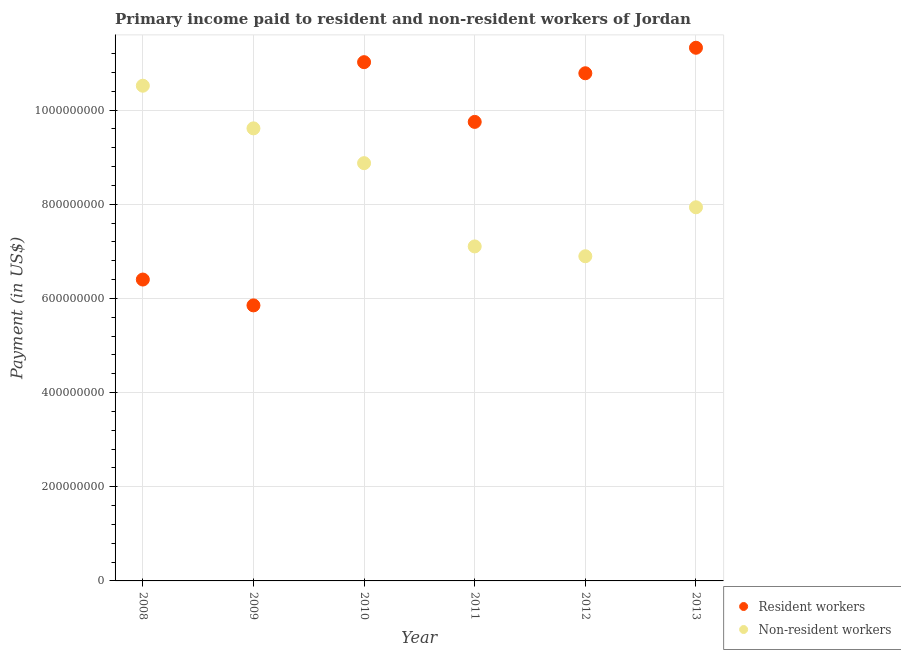What is the payment made to non-resident workers in 2012?
Offer a terse response. 6.90e+08. Across all years, what is the maximum payment made to non-resident workers?
Provide a succinct answer. 1.05e+09. Across all years, what is the minimum payment made to resident workers?
Offer a terse response. 5.85e+08. In which year was the payment made to resident workers maximum?
Provide a succinct answer. 2013. In which year was the payment made to resident workers minimum?
Ensure brevity in your answer.  2009. What is the total payment made to resident workers in the graph?
Keep it short and to the point. 5.51e+09. What is the difference between the payment made to resident workers in 2008 and that in 2012?
Make the answer very short. -4.38e+08. What is the difference between the payment made to resident workers in 2013 and the payment made to non-resident workers in 2008?
Provide a short and direct response. 8.06e+07. What is the average payment made to non-resident workers per year?
Keep it short and to the point. 8.49e+08. In the year 2011, what is the difference between the payment made to non-resident workers and payment made to resident workers?
Offer a very short reply. -2.64e+08. What is the ratio of the payment made to resident workers in 2009 to that in 2011?
Provide a short and direct response. 0.6. Is the payment made to non-resident workers in 2008 less than that in 2013?
Your answer should be compact. No. What is the difference between the highest and the second highest payment made to resident workers?
Give a very brief answer. 3.06e+07. What is the difference between the highest and the lowest payment made to resident workers?
Offer a very short reply. 5.47e+08. In how many years, is the payment made to resident workers greater than the average payment made to resident workers taken over all years?
Offer a terse response. 4. Is the sum of the payment made to resident workers in 2008 and 2010 greater than the maximum payment made to non-resident workers across all years?
Offer a terse response. Yes. Is the payment made to non-resident workers strictly less than the payment made to resident workers over the years?
Keep it short and to the point. No. Does the graph contain any zero values?
Ensure brevity in your answer.  No. Does the graph contain grids?
Keep it short and to the point. Yes. What is the title of the graph?
Provide a succinct answer. Primary income paid to resident and non-resident workers of Jordan. What is the label or title of the X-axis?
Your answer should be compact. Year. What is the label or title of the Y-axis?
Offer a terse response. Payment (in US$). What is the Payment (in US$) of Resident workers in 2008?
Your response must be concise. 6.40e+08. What is the Payment (in US$) of Non-resident workers in 2008?
Offer a very short reply. 1.05e+09. What is the Payment (in US$) of Resident workers in 2009?
Your answer should be very brief. 5.85e+08. What is the Payment (in US$) in Non-resident workers in 2009?
Provide a succinct answer. 9.61e+08. What is the Payment (in US$) in Resident workers in 2010?
Give a very brief answer. 1.10e+09. What is the Payment (in US$) of Non-resident workers in 2010?
Keep it short and to the point. 8.87e+08. What is the Payment (in US$) in Resident workers in 2011?
Your answer should be very brief. 9.75e+08. What is the Payment (in US$) in Non-resident workers in 2011?
Your answer should be very brief. 7.10e+08. What is the Payment (in US$) of Resident workers in 2012?
Give a very brief answer. 1.08e+09. What is the Payment (in US$) in Non-resident workers in 2012?
Your response must be concise. 6.90e+08. What is the Payment (in US$) of Resident workers in 2013?
Offer a terse response. 1.13e+09. What is the Payment (in US$) in Non-resident workers in 2013?
Your response must be concise. 7.94e+08. Across all years, what is the maximum Payment (in US$) in Resident workers?
Your response must be concise. 1.13e+09. Across all years, what is the maximum Payment (in US$) of Non-resident workers?
Make the answer very short. 1.05e+09. Across all years, what is the minimum Payment (in US$) of Resident workers?
Your answer should be very brief. 5.85e+08. Across all years, what is the minimum Payment (in US$) in Non-resident workers?
Ensure brevity in your answer.  6.90e+08. What is the total Payment (in US$) of Resident workers in the graph?
Offer a terse response. 5.51e+09. What is the total Payment (in US$) in Non-resident workers in the graph?
Offer a terse response. 5.09e+09. What is the difference between the Payment (in US$) of Resident workers in 2008 and that in 2009?
Provide a succinct answer. 5.49e+07. What is the difference between the Payment (in US$) of Non-resident workers in 2008 and that in 2009?
Provide a succinct answer. 9.06e+07. What is the difference between the Payment (in US$) in Resident workers in 2008 and that in 2010?
Offer a very short reply. -4.62e+08. What is the difference between the Payment (in US$) in Non-resident workers in 2008 and that in 2010?
Your response must be concise. 1.64e+08. What is the difference between the Payment (in US$) of Resident workers in 2008 and that in 2011?
Your response must be concise. -3.35e+08. What is the difference between the Payment (in US$) of Non-resident workers in 2008 and that in 2011?
Your response must be concise. 3.41e+08. What is the difference between the Payment (in US$) in Resident workers in 2008 and that in 2012?
Give a very brief answer. -4.38e+08. What is the difference between the Payment (in US$) in Non-resident workers in 2008 and that in 2012?
Make the answer very short. 3.62e+08. What is the difference between the Payment (in US$) of Resident workers in 2008 and that in 2013?
Offer a terse response. -4.92e+08. What is the difference between the Payment (in US$) of Non-resident workers in 2008 and that in 2013?
Provide a short and direct response. 2.58e+08. What is the difference between the Payment (in US$) of Resident workers in 2009 and that in 2010?
Your answer should be compact. -5.17e+08. What is the difference between the Payment (in US$) in Non-resident workers in 2009 and that in 2010?
Make the answer very short. 7.39e+07. What is the difference between the Payment (in US$) in Resident workers in 2009 and that in 2011?
Keep it short and to the point. -3.90e+08. What is the difference between the Payment (in US$) of Non-resident workers in 2009 and that in 2011?
Ensure brevity in your answer.  2.51e+08. What is the difference between the Payment (in US$) in Resident workers in 2009 and that in 2012?
Your answer should be very brief. -4.93e+08. What is the difference between the Payment (in US$) in Non-resident workers in 2009 and that in 2012?
Offer a very short reply. 2.72e+08. What is the difference between the Payment (in US$) of Resident workers in 2009 and that in 2013?
Offer a very short reply. -5.47e+08. What is the difference between the Payment (in US$) of Non-resident workers in 2009 and that in 2013?
Your answer should be compact. 1.68e+08. What is the difference between the Payment (in US$) of Resident workers in 2010 and that in 2011?
Your answer should be very brief. 1.27e+08. What is the difference between the Payment (in US$) of Non-resident workers in 2010 and that in 2011?
Your answer should be compact. 1.77e+08. What is the difference between the Payment (in US$) in Resident workers in 2010 and that in 2012?
Offer a terse response. 2.36e+07. What is the difference between the Payment (in US$) in Non-resident workers in 2010 and that in 2012?
Make the answer very short. 1.98e+08. What is the difference between the Payment (in US$) in Resident workers in 2010 and that in 2013?
Your answer should be very brief. -3.06e+07. What is the difference between the Payment (in US$) in Non-resident workers in 2010 and that in 2013?
Your answer should be compact. 9.37e+07. What is the difference between the Payment (in US$) of Resident workers in 2011 and that in 2012?
Provide a short and direct response. -1.03e+08. What is the difference between the Payment (in US$) of Non-resident workers in 2011 and that in 2012?
Provide a succinct answer. 2.09e+07. What is the difference between the Payment (in US$) of Resident workers in 2011 and that in 2013?
Offer a terse response. -1.57e+08. What is the difference between the Payment (in US$) in Non-resident workers in 2011 and that in 2013?
Your answer should be very brief. -8.31e+07. What is the difference between the Payment (in US$) in Resident workers in 2012 and that in 2013?
Your response must be concise. -5.42e+07. What is the difference between the Payment (in US$) in Non-resident workers in 2012 and that in 2013?
Offer a very short reply. -1.04e+08. What is the difference between the Payment (in US$) in Resident workers in 2008 and the Payment (in US$) in Non-resident workers in 2009?
Provide a short and direct response. -3.21e+08. What is the difference between the Payment (in US$) in Resident workers in 2008 and the Payment (in US$) in Non-resident workers in 2010?
Your answer should be compact. -2.47e+08. What is the difference between the Payment (in US$) in Resident workers in 2008 and the Payment (in US$) in Non-resident workers in 2011?
Ensure brevity in your answer.  -7.03e+07. What is the difference between the Payment (in US$) in Resident workers in 2008 and the Payment (in US$) in Non-resident workers in 2012?
Your answer should be compact. -4.95e+07. What is the difference between the Payment (in US$) of Resident workers in 2008 and the Payment (in US$) of Non-resident workers in 2013?
Your answer should be very brief. -1.53e+08. What is the difference between the Payment (in US$) in Resident workers in 2009 and the Payment (in US$) in Non-resident workers in 2010?
Give a very brief answer. -3.02e+08. What is the difference between the Payment (in US$) of Resident workers in 2009 and the Payment (in US$) of Non-resident workers in 2011?
Offer a very short reply. -1.25e+08. What is the difference between the Payment (in US$) in Resident workers in 2009 and the Payment (in US$) in Non-resident workers in 2012?
Make the answer very short. -1.04e+08. What is the difference between the Payment (in US$) of Resident workers in 2009 and the Payment (in US$) of Non-resident workers in 2013?
Ensure brevity in your answer.  -2.08e+08. What is the difference between the Payment (in US$) of Resident workers in 2010 and the Payment (in US$) of Non-resident workers in 2011?
Offer a terse response. 3.91e+08. What is the difference between the Payment (in US$) of Resident workers in 2010 and the Payment (in US$) of Non-resident workers in 2012?
Offer a very short reply. 4.12e+08. What is the difference between the Payment (in US$) in Resident workers in 2010 and the Payment (in US$) in Non-resident workers in 2013?
Provide a short and direct response. 3.08e+08. What is the difference between the Payment (in US$) of Resident workers in 2011 and the Payment (in US$) of Non-resident workers in 2012?
Offer a very short reply. 2.85e+08. What is the difference between the Payment (in US$) in Resident workers in 2011 and the Payment (in US$) in Non-resident workers in 2013?
Ensure brevity in your answer.  1.81e+08. What is the difference between the Payment (in US$) in Resident workers in 2012 and the Payment (in US$) in Non-resident workers in 2013?
Make the answer very short. 2.85e+08. What is the average Payment (in US$) in Resident workers per year?
Your response must be concise. 9.19e+08. What is the average Payment (in US$) in Non-resident workers per year?
Your response must be concise. 8.49e+08. In the year 2008, what is the difference between the Payment (in US$) of Resident workers and Payment (in US$) of Non-resident workers?
Provide a short and direct response. -4.12e+08. In the year 2009, what is the difference between the Payment (in US$) of Resident workers and Payment (in US$) of Non-resident workers?
Give a very brief answer. -3.76e+08. In the year 2010, what is the difference between the Payment (in US$) in Resident workers and Payment (in US$) in Non-resident workers?
Your answer should be very brief. 2.14e+08. In the year 2011, what is the difference between the Payment (in US$) of Resident workers and Payment (in US$) of Non-resident workers?
Provide a short and direct response. 2.64e+08. In the year 2012, what is the difference between the Payment (in US$) in Resident workers and Payment (in US$) in Non-resident workers?
Offer a very short reply. 3.89e+08. In the year 2013, what is the difference between the Payment (in US$) of Resident workers and Payment (in US$) of Non-resident workers?
Your response must be concise. 3.39e+08. What is the ratio of the Payment (in US$) of Resident workers in 2008 to that in 2009?
Your response must be concise. 1.09. What is the ratio of the Payment (in US$) of Non-resident workers in 2008 to that in 2009?
Offer a very short reply. 1.09. What is the ratio of the Payment (in US$) in Resident workers in 2008 to that in 2010?
Keep it short and to the point. 0.58. What is the ratio of the Payment (in US$) of Non-resident workers in 2008 to that in 2010?
Ensure brevity in your answer.  1.19. What is the ratio of the Payment (in US$) of Resident workers in 2008 to that in 2011?
Keep it short and to the point. 0.66. What is the ratio of the Payment (in US$) in Non-resident workers in 2008 to that in 2011?
Keep it short and to the point. 1.48. What is the ratio of the Payment (in US$) of Resident workers in 2008 to that in 2012?
Your answer should be very brief. 0.59. What is the ratio of the Payment (in US$) in Non-resident workers in 2008 to that in 2012?
Offer a terse response. 1.53. What is the ratio of the Payment (in US$) in Resident workers in 2008 to that in 2013?
Your response must be concise. 0.57. What is the ratio of the Payment (in US$) in Non-resident workers in 2008 to that in 2013?
Keep it short and to the point. 1.33. What is the ratio of the Payment (in US$) of Resident workers in 2009 to that in 2010?
Your answer should be compact. 0.53. What is the ratio of the Payment (in US$) in Non-resident workers in 2009 to that in 2010?
Your response must be concise. 1.08. What is the ratio of the Payment (in US$) in Resident workers in 2009 to that in 2011?
Make the answer very short. 0.6. What is the ratio of the Payment (in US$) of Non-resident workers in 2009 to that in 2011?
Your answer should be very brief. 1.35. What is the ratio of the Payment (in US$) of Resident workers in 2009 to that in 2012?
Offer a terse response. 0.54. What is the ratio of the Payment (in US$) of Non-resident workers in 2009 to that in 2012?
Keep it short and to the point. 1.39. What is the ratio of the Payment (in US$) of Resident workers in 2009 to that in 2013?
Ensure brevity in your answer.  0.52. What is the ratio of the Payment (in US$) in Non-resident workers in 2009 to that in 2013?
Provide a succinct answer. 1.21. What is the ratio of the Payment (in US$) of Resident workers in 2010 to that in 2011?
Provide a short and direct response. 1.13. What is the ratio of the Payment (in US$) of Non-resident workers in 2010 to that in 2011?
Your answer should be very brief. 1.25. What is the ratio of the Payment (in US$) in Resident workers in 2010 to that in 2012?
Ensure brevity in your answer.  1.02. What is the ratio of the Payment (in US$) of Non-resident workers in 2010 to that in 2012?
Give a very brief answer. 1.29. What is the ratio of the Payment (in US$) in Non-resident workers in 2010 to that in 2013?
Your answer should be compact. 1.12. What is the ratio of the Payment (in US$) in Resident workers in 2011 to that in 2012?
Keep it short and to the point. 0.9. What is the ratio of the Payment (in US$) in Non-resident workers in 2011 to that in 2012?
Your answer should be very brief. 1.03. What is the ratio of the Payment (in US$) of Resident workers in 2011 to that in 2013?
Offer a very short reply. 0.86. What is the ratio of the Payment (in US$) in Non-resident workers in 2011 to that in 2013?
Offer a very short reply. 0.9. What is the ratio of the Payment (in US$) of Resident workers in 2012 to that in 2013?
Offer a very short reply. 0.95. What is the ratio of the Payment (in US$) in Non-resident workers in 2012 to that in 2013?
Make the answer very short. 0.87. What is the difference between the highest and the second highest Payment (in US$) in Resident workers?
Provide a short and direct response. 3.06e+07. What is the difference between the highest and the second highest Payment (in US$) of Non-resident workers?
Your response must be concise. 9.06e+07. What is the difference between the highest and the lowest Payment (in US$) in Resident workers?
Keep it short and to the point. 5.47e+08. What is the difference between the highest and the lowest Payment (in US$) of Non-resident workers?
Provide a short and direct response. 3.62e+08. 